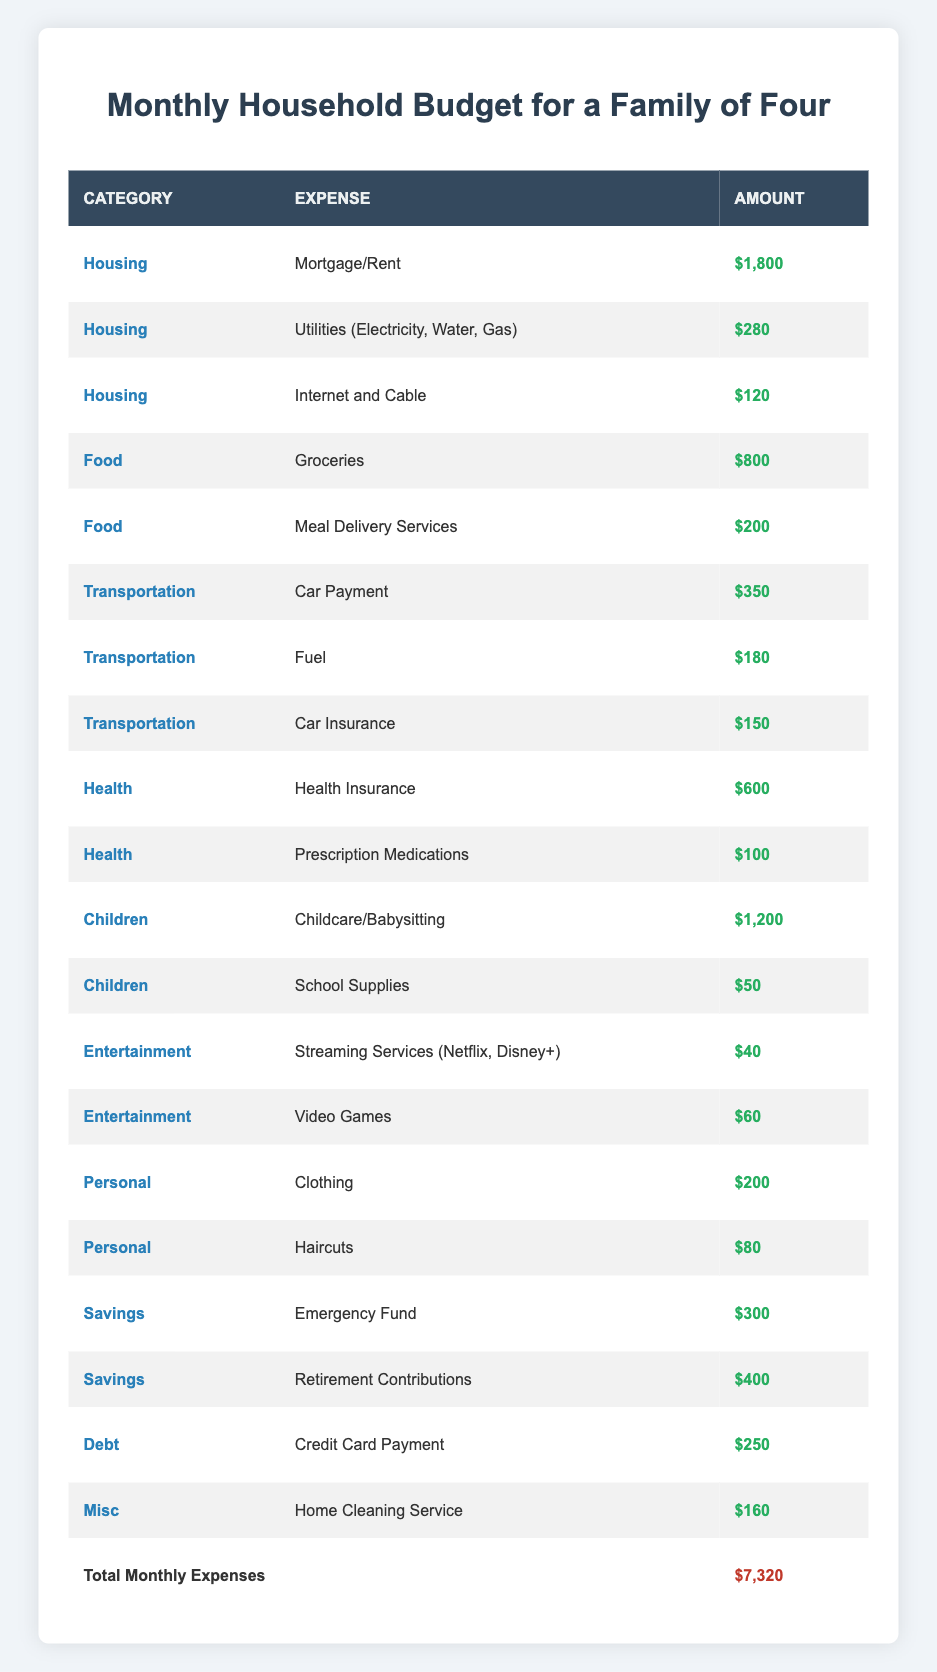What is the total amount spent on Housing? To find the total amount spent on Housing, we need to sum all expenses listed under the Housing category. The expenses are: Mortgage/Rent ($1,800), Utilities ($280), and Internet and Cable ($120). Adding these amounts together: 1,800 + 280 + 120 = 2,200.
Answer: 2,200 How much is spent on Food compared to Transportation? First, we sum the Food expenses: Groceries ($800) and Meal Delivery Services ($200) gives us 800 + 200 = 1,000. Next, for Transportation, we sum: Car Payment ($350), Fuel ($180), and Car Insurance ($150), which totals 350 + 180 + 150 = 680. Lastly, we compare the two totals: 1,000 (Food) versus 680 (Transportation).
Answer: Food expenses are higher Is the amount spent on Childcare/Babysitting more than that spent on Health Insurance? The amount for Childcare/Babysitting is $1,200. The amount for Health Insurance is $600. When comparing the two: $1,200 is greater than $600.
Answer: Yes What is the total for all Expenses listed under Personal? To find the total for Personal expenses, we need to sum: Clothing ($200) and Haircuts ($80). Adding these amounts together gives us 200 + 80 = 280.
Answer: 280 What percentage of the total monthly expenses is spent on Debt? First, find the total monthly expenses, which is $7,320. The Debt expense is $250. To calculate the percentage of Debt: (250 / 7,320) * 100 = approximately 3.42%.
Answer: Approximately 3.42% How much is spent on Savings versus Entertainment? For Savings, we have Emergency Fund ($300) and Retirement Contributions ($400), totaling 300 + 400 = 700. For Entertainment, we sum Streaming Services ($40) and Video Games ($60), giving us 40 + 60 = 100. Comparing the two: 700 (Savings) versus 100 (Entertainment).
Answer: Savings are higher Is the total spending on Miscellaneous greater than the total for Food? The total for Miscellaneous is $160. The total for Food, as calculated earlier, is $1,000. Since $160 is less than $1,000, we find that the criterion is not met.
Answer: No What are the combined expenses for Health? The expenses for Health are Health Insurance ($600) and Prescription Medications ($100). Adding these gives us 600 + 100 = 700.
Answer: 700 Which category has the highest single expense? Looking through the data, Childcare/Babysitting stands out with an expense of $1,200, which is higher than any other single expense listed in other categories, such as Housing or Food.
Answer: Children 